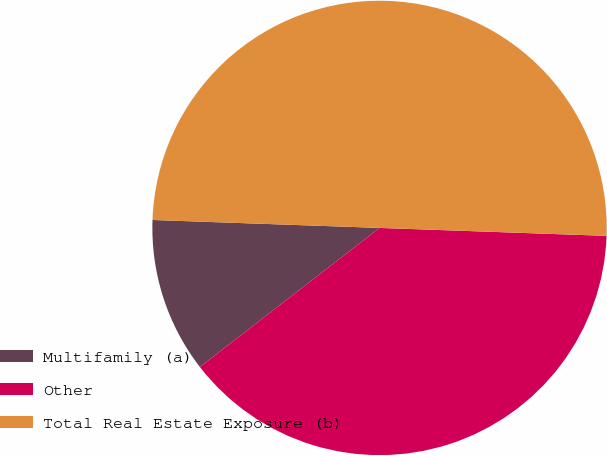<chart> <loc_0><loc_0><loc_500><loc_500><pie_chart><fcel>Multifamily (a)<fcel>Other<fcel>Total Real Estate Exposure (b)<nl><fcel>11.04%<fcel>38.96%<fcel>50.0%<nl></chart> 